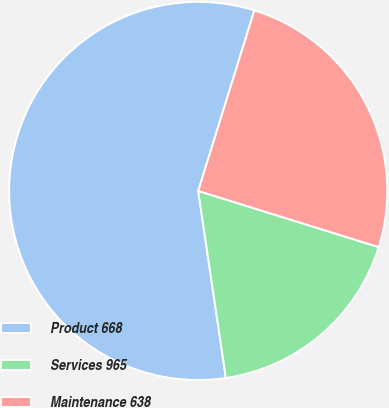Convert chart. <chart><loc_0><loc_0><loc_500><loc_500><pie_chart><fcel>Product 668<fcel>Services 965<fcel>Maintenance 638<nl><fcel>57.14%<fcel>17.86%<fcel>25.0%<nl></chart> 